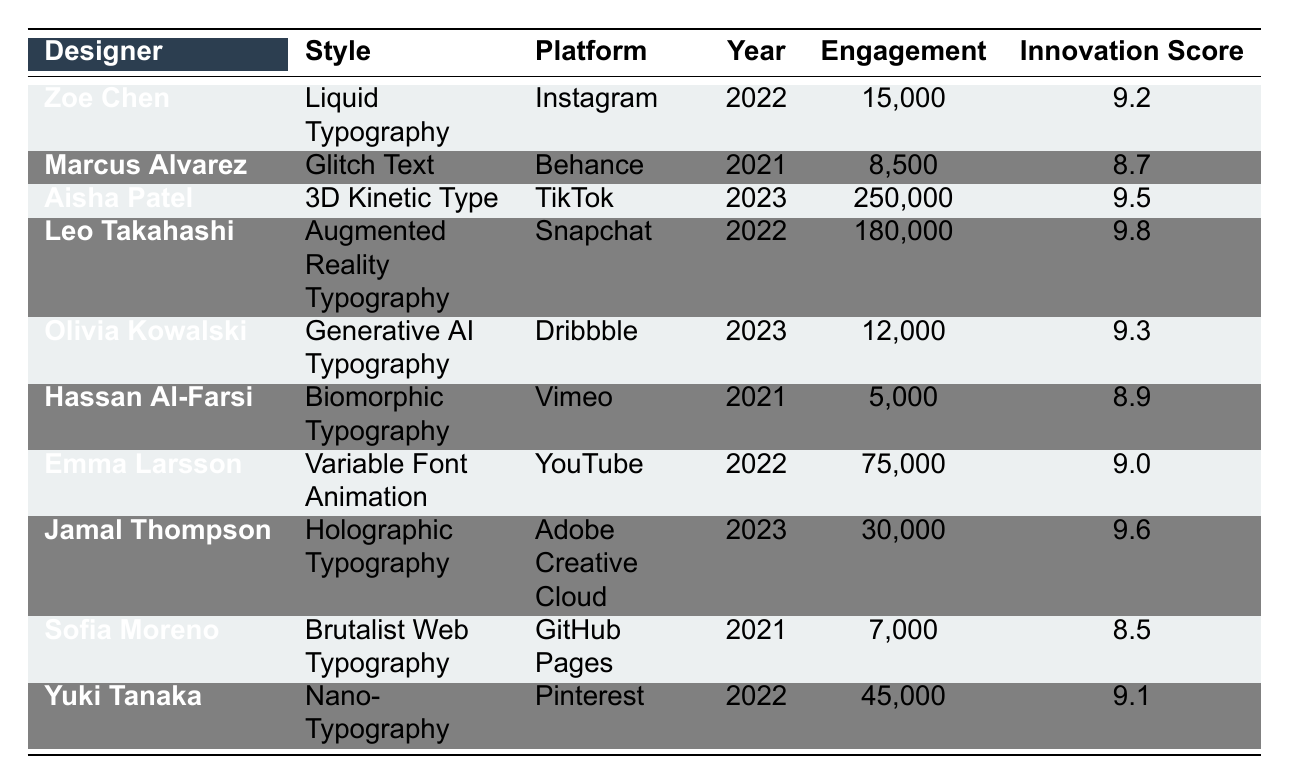What is the highest innovation score among the experimental typography styles? The highest innovation score in the table is found next to Leo Takahashi with a score of 9.8.
Answer: 9.8 Which designer has the lowest engagement? The designer with the lowest engagement is Hassan Al-Farsi, who achieved 5,000 engagements.
Answer: 5,000 How many designers have an innovation score of 9.0 or higher? There are 6 designers with an innovation score of 9.0 or higher: Zoe Chen, Aisha Patel, Leo Takahashi, Olivia Kowalski, Jamal Thompson, and Yuki Tanaka.
Answer: 6 What is the average engagement of all designers listed? First, we sum up all engagements: 15,000 + 8,500 + 250,000 + 180,000 + 12,000 + 5,000 + 75,000 + 30,000 + 7,000 + 45,000 = 312,500. There are 10 designers, so the average engagement is 312,500 / 10 = 31,250.
Answer: 31,250 Is there any designer from TikTok? Yes, Aisha Patel is the designer who showcases her work on TikTok.
Answer: Yes Which typography style had the highest engagement in 2023? Aisha Patel's 3D Kinetic Type had the highest engagement in 2023, with 250,000 engagements.
Answer: 250,000 What is the difference in engagement between Leo Takahashi and Sofia Moreno? Leo Takahashi had 180,000 engagements, and Sofia Moreno had 7,000 engagements. The difference is 180,000 - 7,000 = 173,000.
Answer: 173,000 Which designer used Brutalist Web Typography, and what was their innovation score? Sofia Moreno used Brutalist Web Typography, and her innovation score is 8.5.
Answer: 8.5 What percentage of total engagements was contributed by Aisha Patel? Aisha Patel had 250,000 engagements. The total engagements are 312,500 (from previous calculation). The percentage is (250,000 / 312,500) * 100 = 80%.
Answer: 80% Among the styles listed from 2021, which had the highest innovation score? From the 2021 styles, Marcus Alvarez with Glitch Text had an innovation score of 8.7, while Hassan Al-Farsi with Biomorphic Typography had 8.9. Thus, Hassan Al-Farsi's style had the highest score of 8.9.
Answer: 8.9 